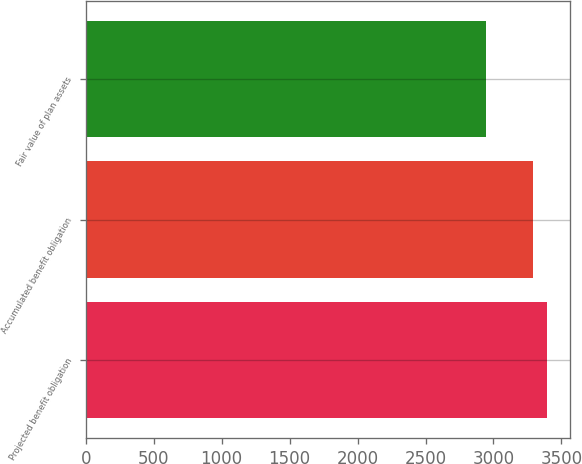Convert chart. <chart><loc_0><loc_0><loc_500><loc_500><bar_chart><fcel>Projected benefit obligation<fcel>Accumulated benefit obligation<fcel>Fair value of plan assets<nl><fcel>3390.9<fcel>3289.3<fcel>2942.5<nl></chart> 